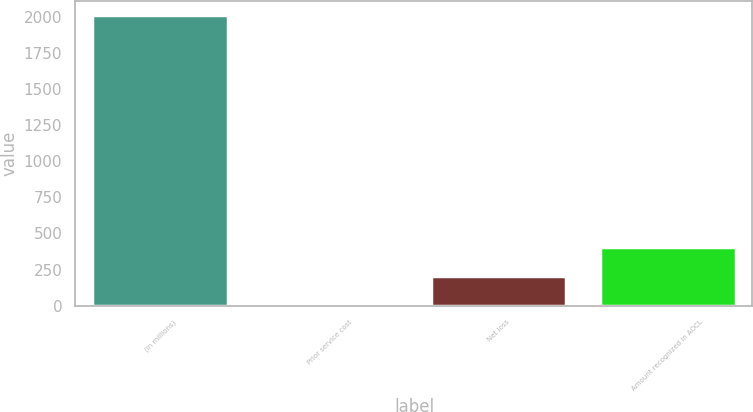<chart> <loc_0><loc_0><loc_500><loc_500><bar_chart><fcel>(in millions)<fcel>Prior service cost<fcel>Net loss<fcel>Amount recognized in AOCL<nl><fcel>2010<fcel>2.5<fcel>203.25<fcel>404<nl></chart> 